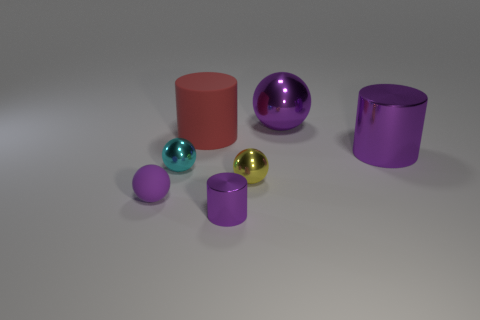Subtract all cyan balls. How many purple cylinders are left? 2 Subtract all green spheres. Subtract all cyan cubes. How many spheres are left? 4 Add 1 big green rubber spheres. How many objects exist? 8 Subtract all spheres. How many objects are left? 3 Add 1 tiny yellow balls. How many tiny yellow balls exist? 2 Subtract 0 green blocks. How many objects are left? 7 Subtract all large red metal objects. Subtract all red objects. How many objects are left? 6 Add 7 tiny metal objects. How many tiny metal objects are left? 10 